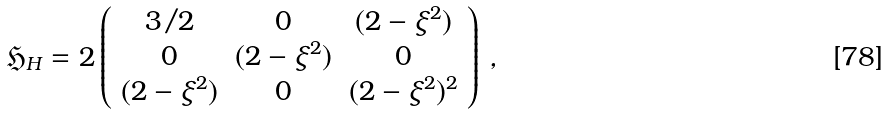<formula> <loc_0><loc_0><loc_500><loc_500>\mathfrak { H } _ { H } = 2 \left ( \begin{array} { c c c } 3 / 2 & 0 & ( 2 - \xi ^ { 2 } ) \\ 0 & ( 2 - \xi ^ { 2 } ) & 0 \\ ( 2 - \xi ^ { 2 } ) & 0 & ( 2 - \xi ^ { 2 } ) ^ { 2 } \end{array} \right ) \, ,</formula> 